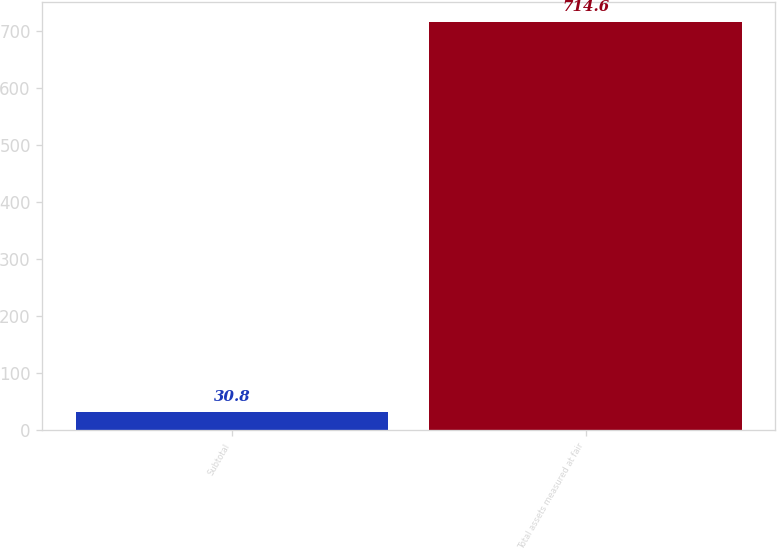<chart> <loc_0><loc_0><loc_500><loc_500><bar_chart><fcel>Subtotal<fcel>Total assets measured at fair<nl><fcel>30.8<fcel>714.6<nl></chart> 